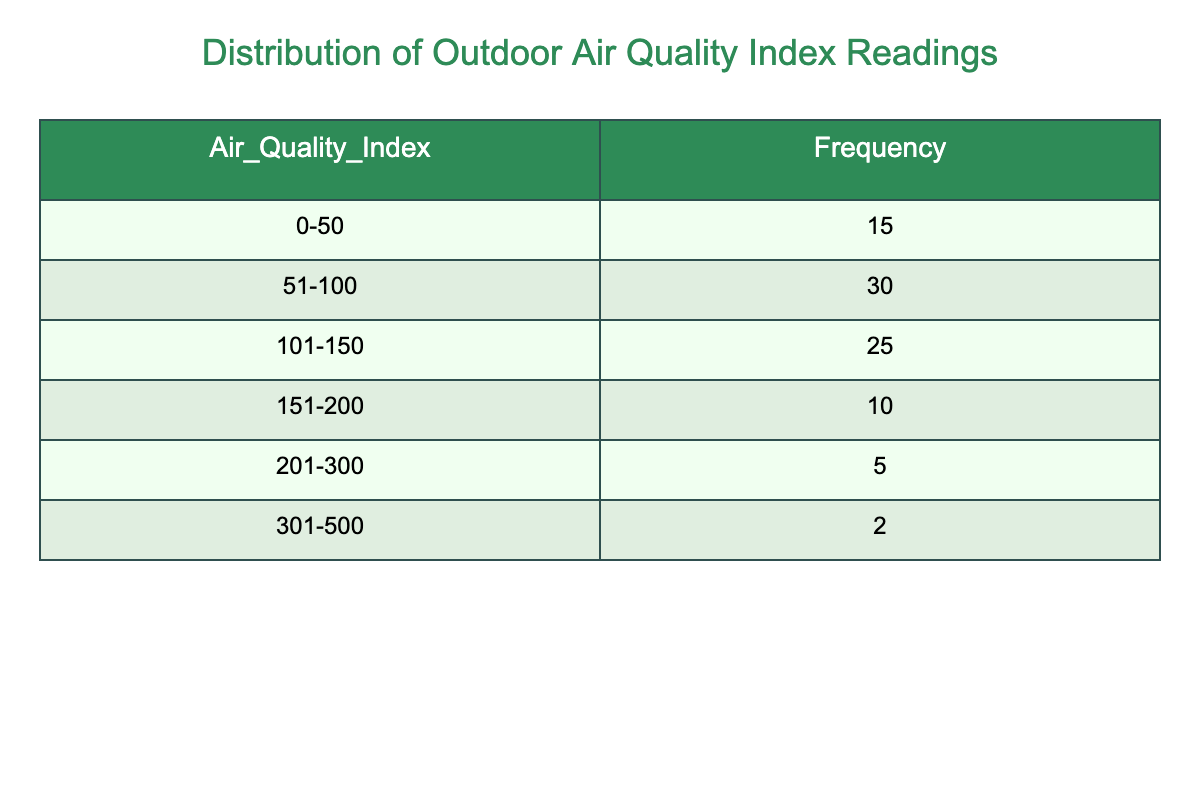What is the frequency of outdoor air quality index readings in the range 51-100? According to the table, the frequency of readings in the range 51-100 is explicitly listed as 30.
Answer: 30 How many readings fall into the category of 151-200? The table shows that the frequency of readings within the 151-200 range is 10.
Answer: 10 What is the total frequency of air quality index readings from 0-150? To find the total frequency from 0-150, we add the frequencies of the ranges 0-50 (15), 51-100 (30), and 101-150 (25). The total is 15 + 30 + 25 = 70.
Answer: 70 Is there a category with more than 40 readings? By examining the frequencies, the ranges 51-100 (30), and 101-150 (25) have fewer than or equal to 40 readings; however, 0-50 has 15 readings and 151-200 has 10 readings, confirming that none exceed 40.
Answer: No What percentage of the readings fall within the air quality index range 0-50 compared to the total? The total frequency is 15 + 30 + 25 + 10 + 5 + 2 = 87. The frequency for 0-50 is 15. To find the percentage, we calculate (15/87) * 100 which is approximately 17.24%.
Answer: 17.24% Which range has the least frequency of air quality index readings, and how many? The least frequency is in the range 301-500, which has 2 readings as listed in the table.
Answer: 301-500, 2 What is the difference in frequency between the 101-150 range and the 201-300 range? The frequency for the 101-150 range is 25, while for the 201-300 range, it is 5. The difference is 25 - 5 = 20.
Answer: 20 How many total readings are in the 201-300 and 301-500 ranges combined? The frequency for the 201-300 range is 5 and for the 301-500 range is 2. Adding these, we get 5 + 2 = 7.
Answer: 7 Are there more readings in the range 0-50 than in the range 201-300? The frequency for 0-50 is 15 and for 201-300, it is 5. Since 15 is greater than 5, the statement is true.
Answer: Yes What is the average number of readings across all ranges? The total frequency, as calculated earlier, is 87. There are 6 ranges, so the average is 87/6 = 14.5.
Answer: 14.5 